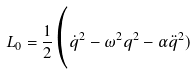Convert formula to latex. <formula><loc_0><loc_0><loc_500><loc_500>L _ { 0 } = \frac { 1 } { 2 } \Big ( \dot { q } ^ { 2 } - \omega ^ { 2 } q ^ { 2 } - \alpha \ddot { q } ^ { 2 } )</formula> 